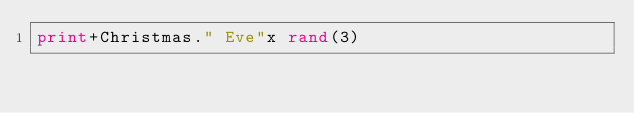<code> <loc_0><loc_0><loc_500><loc_500><_Perl_>print+Christmas." Eve"x rand(3)</code> 